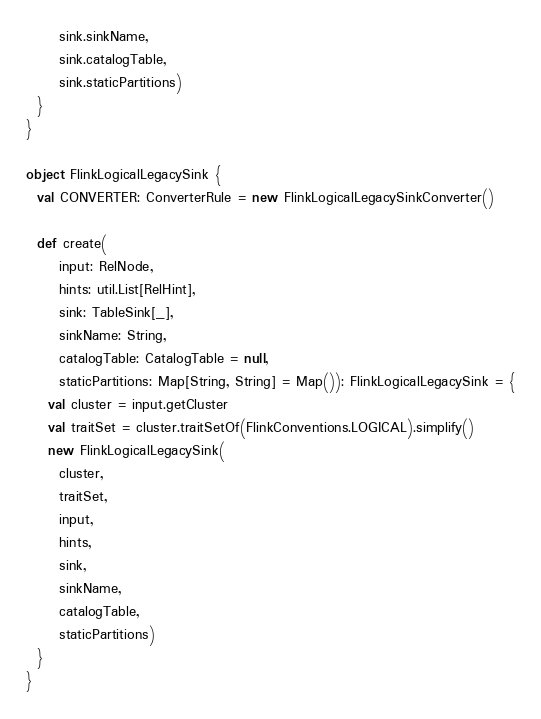<code> <loc_0><loc_0><loc_500><loc_500><_Scala_>      sink.sinkName,
      sink.catalogTable,
      sink.staticPartitions)
  }
}

object FlinkLogicalLegacySink {
  val CONVERTER: ConverterRule = new FlinkLogicalLegacySinkConverter()

  def create(
      input: RelNode,
      hints: util.List[RelHint],
      sink: TableSink[_],
      sinkName: String,
      catalogTable: CatalogTable = null,
      staticPartitions: Map[String, String] = Map()): FlinkLogicalLegacySink = {
    val cluster = input.getCluster
    val traitSet = cluster.traitSetOf(FlinkConventions.LOGICAL).simplify()
    new FlinkLogicalLegacySink(
      cluster,
      traitSet,
      input,
      hints,
      sink,
      sinkName,
      catalogTable,
      staticPartitions)
  }
}
</code> 